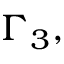<formula> <loc_0><loc_0><loc_500><loc_500>\Gamma _ { 3 } ,</formula> 